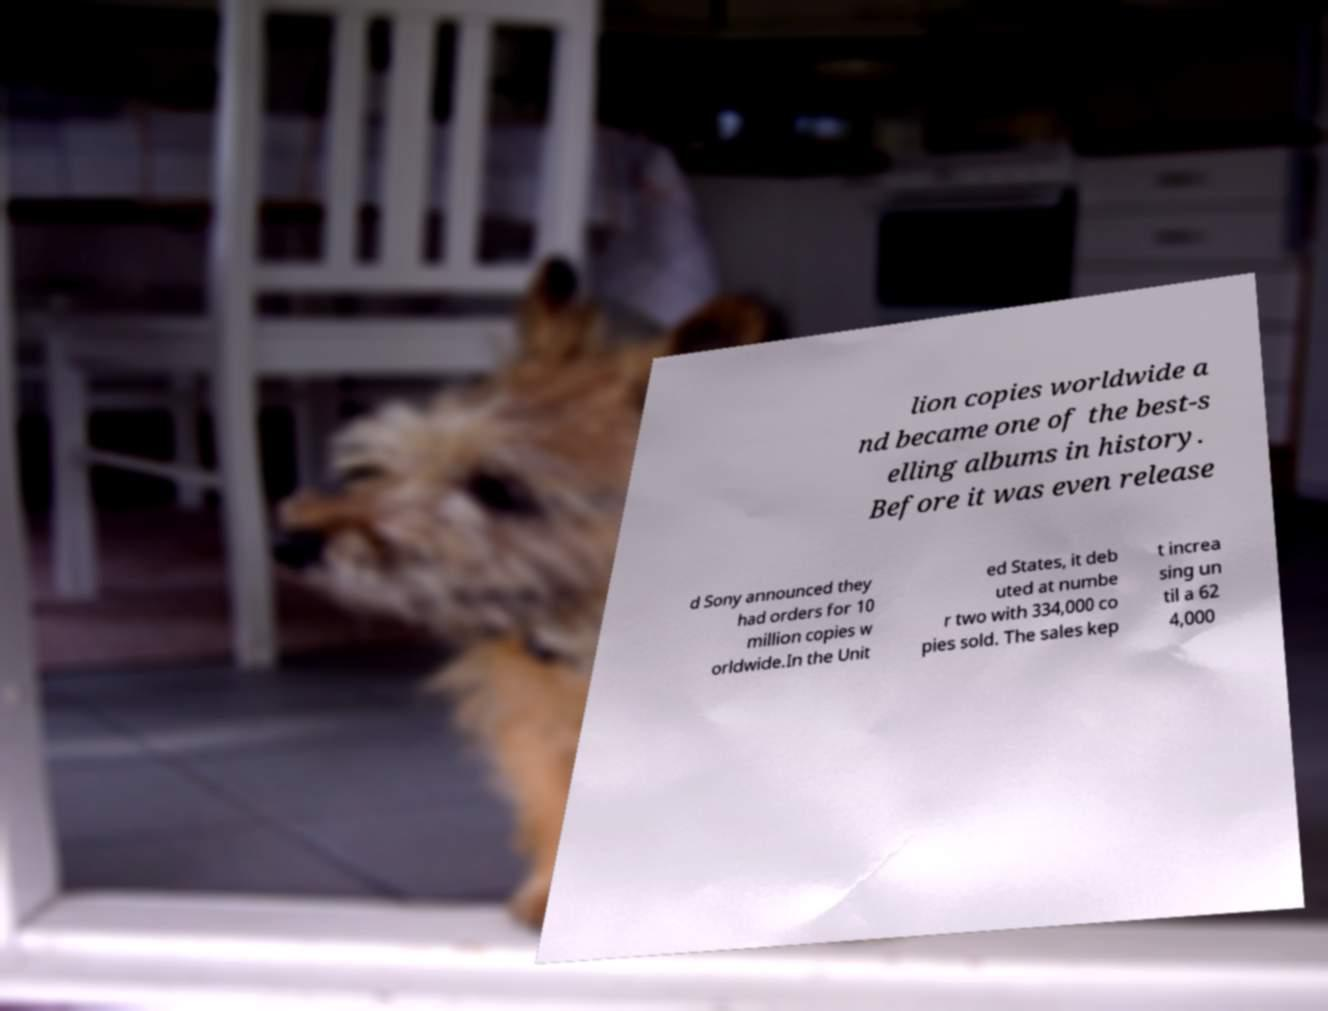What messages or text are displayed in this image? I need them in a readable, typed format. lion copies worldwide a nd became one of the best-s elling albums in history. Before it was even release d Sony announced they had orders for 10 million copies w orldwide.In the Unit ed States, it deb uted at numbe r two with 334,000 co pies sold. The sales kep t increa sing un til a 62 4,000 